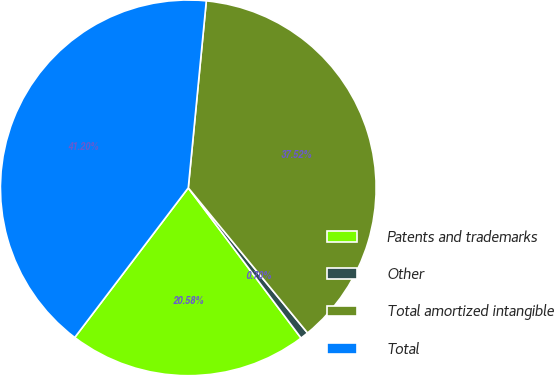Convert chart. <chart><loc_0><loc_0><loc_500><loc_500><pie_chart><fcel>Patents and trademarks<fcel>Other<fcel>Total amortized intangible<fcel>Total<nl><fcel>20.58%<fcel>0.7%<fcel>37.52%<fcel>41.2%<nl></chart> 